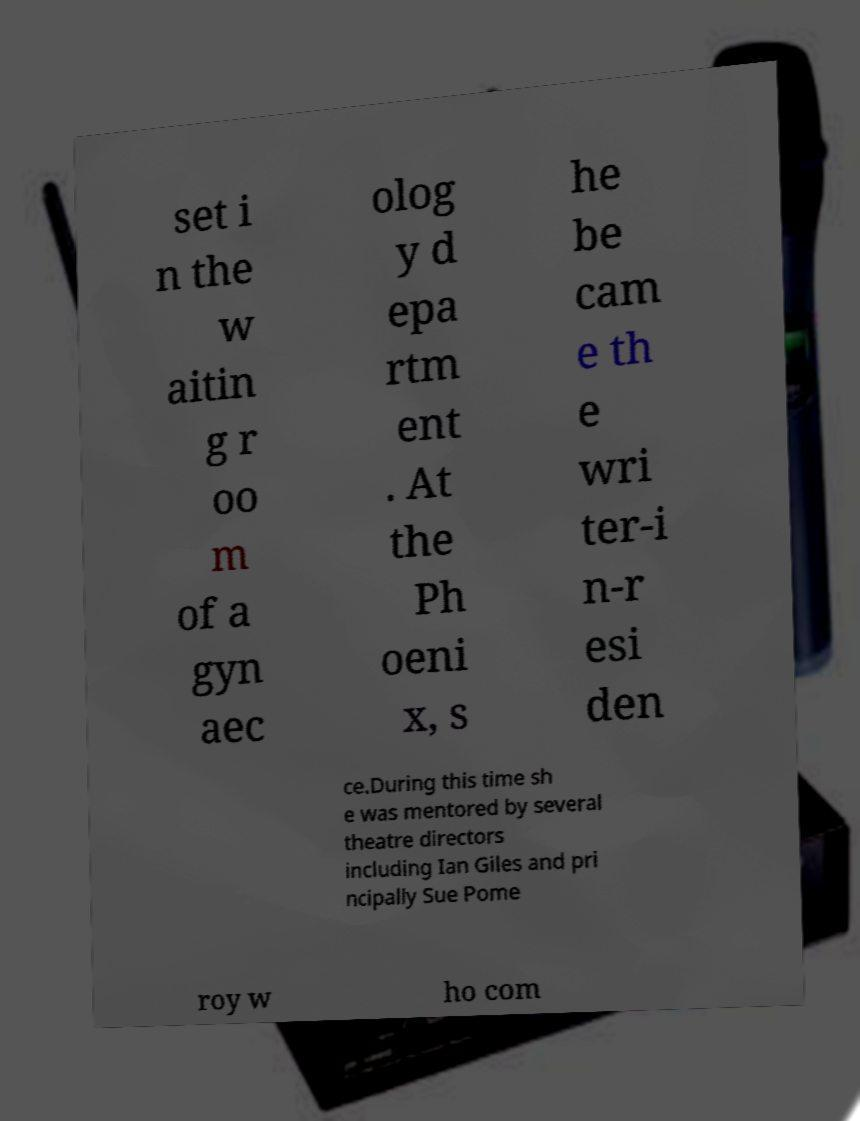For documentation purposes, I need the text within this image transcribed. Could you provide that? set i n the w aitin g r oo m of a gyn aec olog y d epa rtm ent . At the Ph oeni x, s he be cam e th e wri ter-i n-r esi den ce.During this time sh e was mentored by several theatre directors including Ian Giles and pri ncipally Sue Pome roy w ho com 